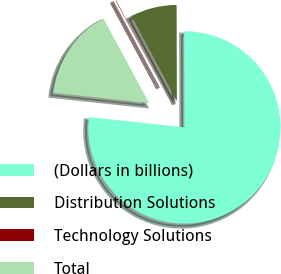Convert chart. <chart><loc_0><loc_0><loc_500><loc_500><pie_chart><fcel>(Dollars in billions)<fcel>Distribution Solutions<fcel>Technology Solutions<fcel>Total<nl><fcel>76.76%<fcel>7.75%<fcel>0.08%<fcel>15.41%<nl></chart> 